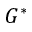Convert formula to latex. <formula><loc_0><loc_0><loc_500><loc_500>G ^ { * }</formula> 